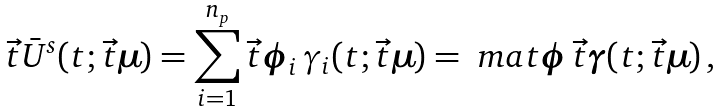<formula> <loc_0><loc_0><loc_500><loc_500>\vec { t } { \bar { U } } ^ { s } ( t ; \vec { t } { \boldsymbol \mu } ) = \sum _ { i = 1 } ^ { n _ { p } } \vec { t } { \boldsymbol \phi } _ { i } \, \gamma _ { i } ( t ; \vec { t } { \boldsymbol \mu } ) = \ m a t { \boldsymbol \phi } \, \vec { t } { \boldsymbol \gamma } ( t ; \vec { t } { \boldsymbol \mu } ) \, ,</formula> 